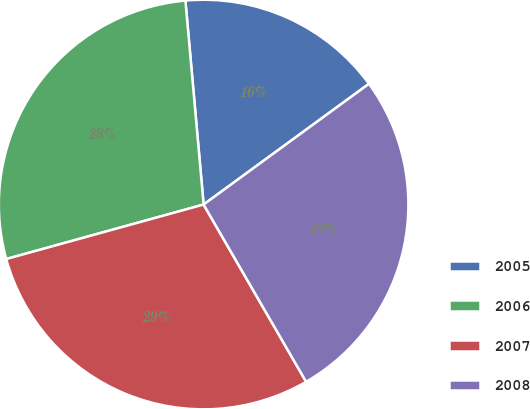<chart> <loc_0><loc_0><loc_500><loc_500><pie_chart><fcel>2005<fcel>2006<fcel>2007<fcel>2008<nl><fcel>16.38%<fcel>27.87%<fcel>29.06%<fcel>26.69%<nl></chart> 